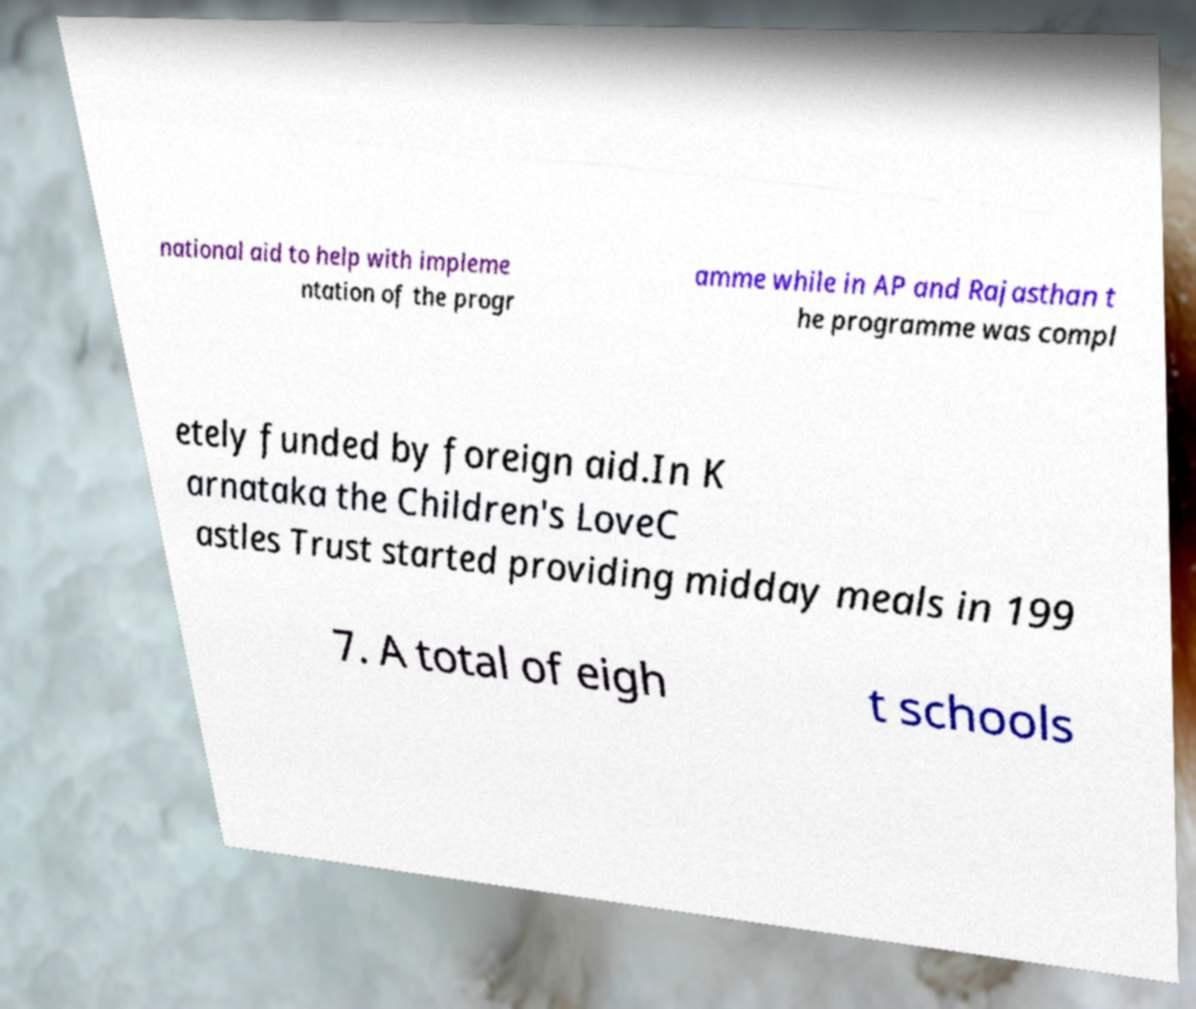Could you extract and type out the text from this image? national aid to help with impleme ntation of the progr amme while in AP and Rajasthan t he programme was compl etely funded by foreign aid.In K arnataka the Children's LoveC astles Trust started providing midday meals in 199 7. A total of eigh t schools 